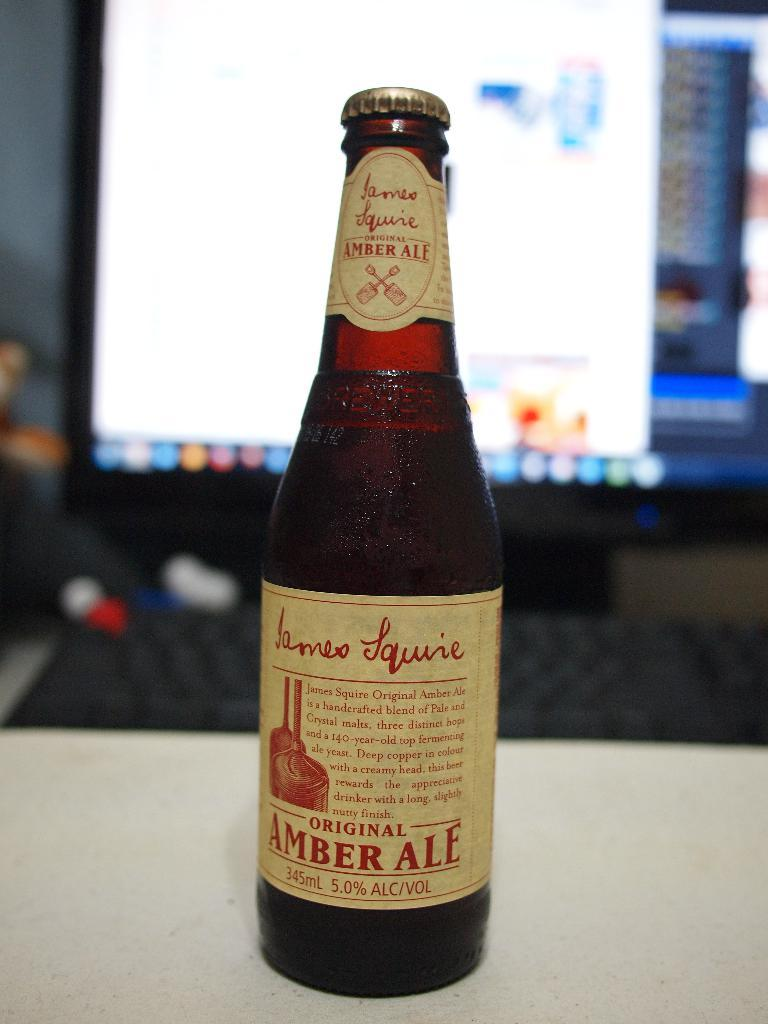<image>
Write a terse but informative summary of the picture. A bottle with a label stating Original Amber Ale. 